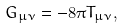<formula> <loc_0><loc_0><loc_500><loc_500>G _ { \mu \nu } = - 8 \pi T _ { \mu \nu } ,</formula> 